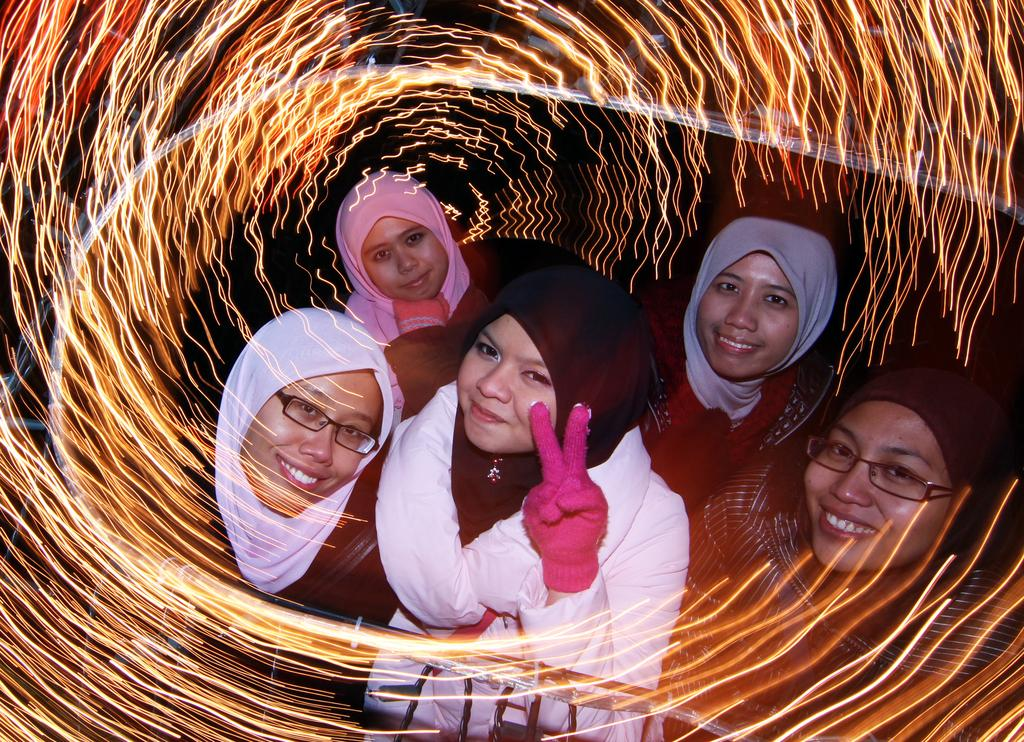How many ladies are present in the image? There are five ladies in the image. What is a common accessory worn by all the ladies in the image? All the ladies are wearing scarves on their heads. How many ladies are wearing glasses in the image? Two of the ladies are wearing glasses. What additional accessory is worn by one of the ladies? One lady is wearing gloves. Can you describe the visual effect applied to the image? There is a photo effect applied to the image. What type of toothpaste is being used by the lady wearing gloves in the image? There is no toothpaste present in the image, and the lady wearing gloves is not using any toothpaste. What material is the scarecrow made of in the image? There is no scarecrow present in the image. 